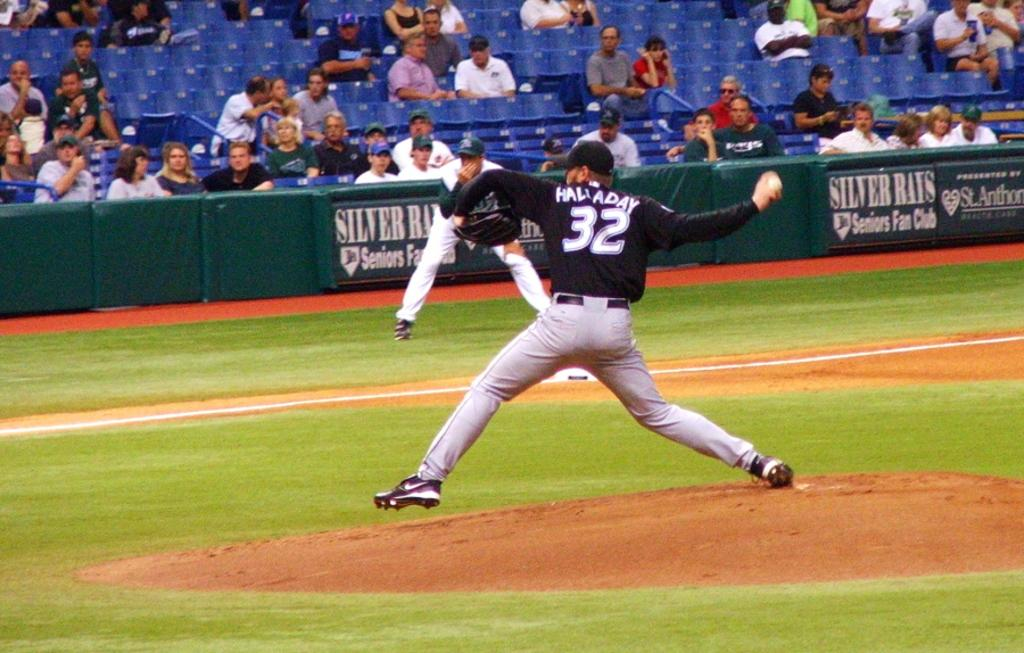<image>
Provide a brief description of the given image. Hallady, the number 32 Baseball player throws the ball as an opponent watches on in front of advertising boards for Silver Ray Seniors Fan Club 